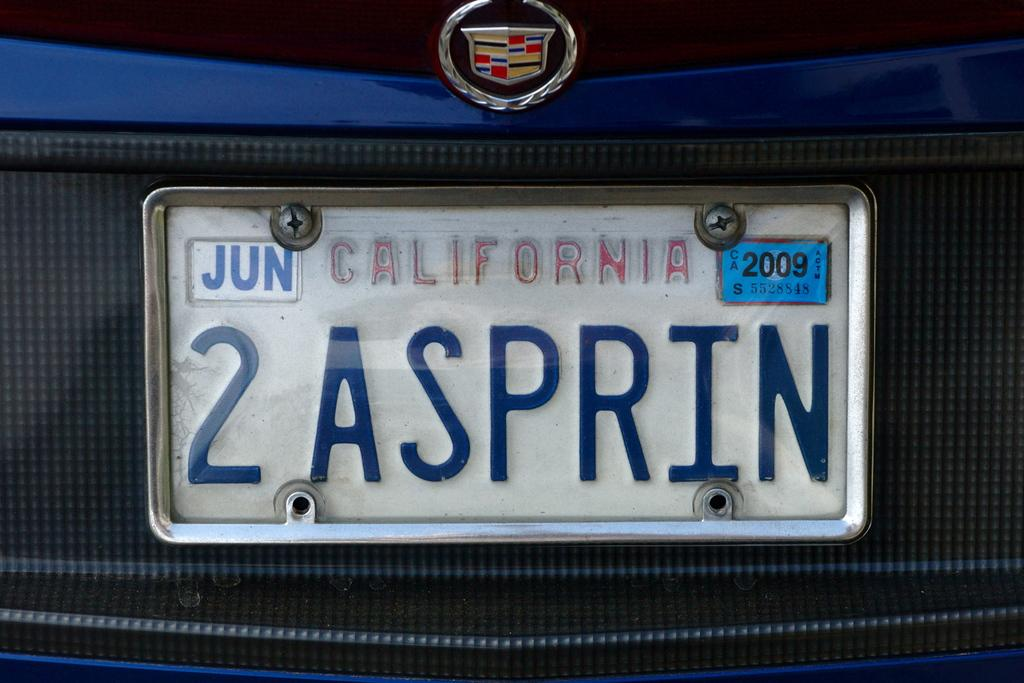Provide a one-sentence caption for the provided image. A close up the licence plate of a blue and gray car registered in California. 